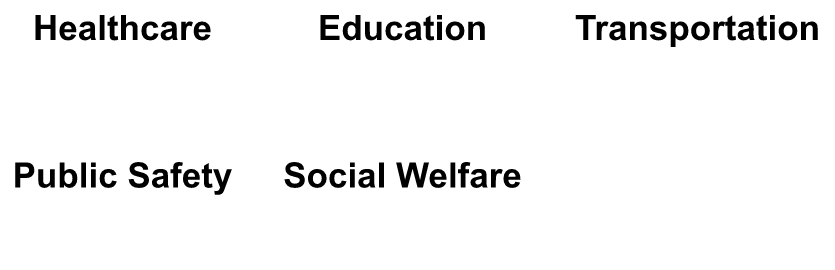What is the title of the first subplot? The first subplot represents healthcare and its title is placed prominently at the top of the polar chart.
Answer: Healthcare What are the highest and lowest scores for the Transportation category? The highest score for Transportation is 72 for Efficiency, and the lowest score is 50 for Infrastructure.
Answer: Highest: 72, Lowest: 50 How does the average score for Public Safety compare to Social Welfare? For Public Safety, the scores are 70, 75, 60, and 65. The average is (70+75+60+65)/4 = 67.5. For Social Welfare, the scores are 65, 62, 55, and 50. The average is (65+62+55+50)/4 = 58. The average for Public Safety is higher.
Answer: Public Safety: 67.5, Social Welfare: 58 Which category has the highest score in the Education subplot? In the Education subplot, Teacher Quality has the highest score of 75.
Answer: Teacher Quality (75) Is Accessibility rated higher in Healthcare or Social Welfare? Accessibility is rated 70 in Healthcare and 62 in Social Welfare. Therefore, it is rated higher in Healthcare.
Answer: Healthcare (70) What is the difference in scores between Response Time and Trust in the Public Safety category? The score for Response Time is 70, and for Trust, it is 60. The difference is 70 - 60 = 10.
Answer: 10 In the Social Welfare category, which aspect has the most significant dissatisfaction (lowest score)? In Social Welfare, the lowest score is for Adequacy with a score of 50.
Answer: Adequacy (50) What is the combined score for satisfied opinions (Quality and Accessibility) in Healthcare? The scores for Satisfied opinions in Healthcare are 65 (Quality) and 70 (Accessibility). The combined score is 65 + 70 = 135.
Answer: 135 Comparing satisfied opinions, which category shows more satisfaction: Teacher Quality in Education or Presence in Public Safety? Teacher Quality in Education has a score of 75, and Presence in Public Safety also has a score of 75. Therefore, the satisfaction level is equal.
Answer: Equal (75 each) How do the scores for Cost compare between Healthcare and Transportation? The score for Cost in Healthcare is 45, and for Transportation, it is 55. Cost is rated higher in Transportation.
Answer: Healthcare: 45, Transportation: 55 